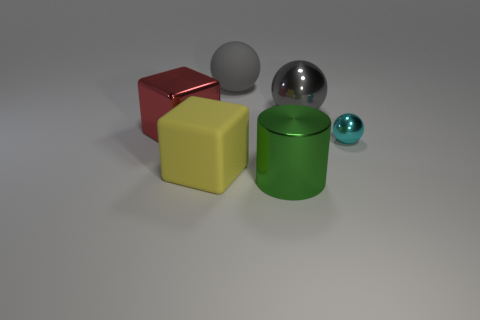Subtract all gray spheres. How many spheres are left? 1 Add 1 large gray things. How many objects exist? 7 Subtract all red cubes. How many cubes are left? 1 Subtract all brown blocks. How many gray balls are left? 2 Subtract all cylinders. How many objects are left? 5 Subtract 2 spheres. How many spheres are left? 1 Subtract all tiny cyan shiny spheres. Subtract all green cylinders. How many objects are left? 4 Add 2 big metal things. How many big metal things are left? 5 Add 1 purple balls. How many purple balls exist? 1 Subtract 0 brown blocks. How many objects are left? 6 